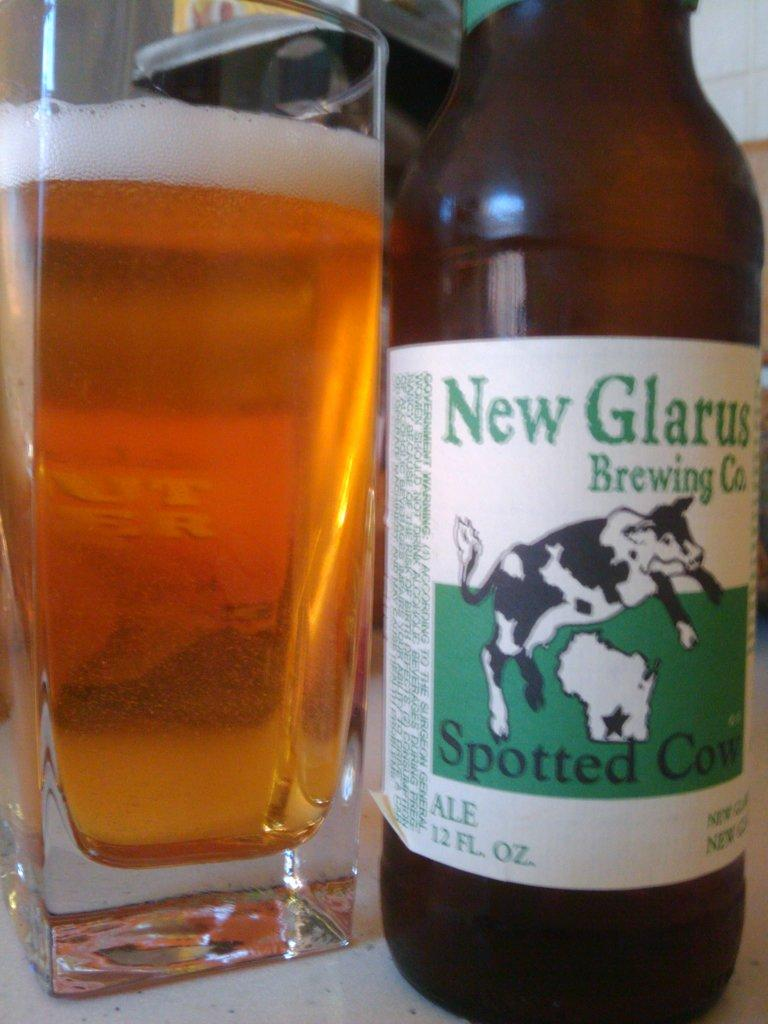<image>
Render a clear and concise summary of the photo. A bottle of Spotted Cow beer made by New Glarus Brewing Company. 